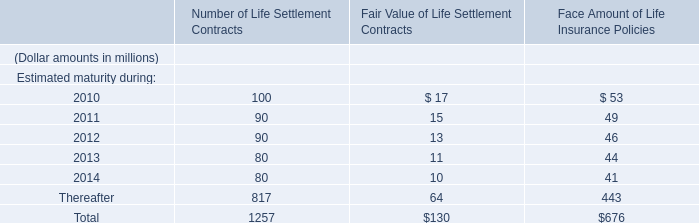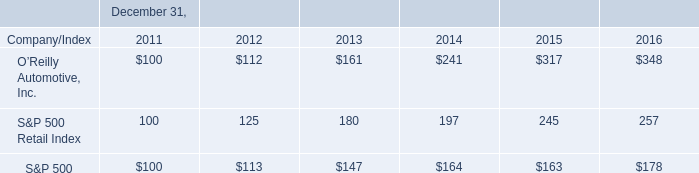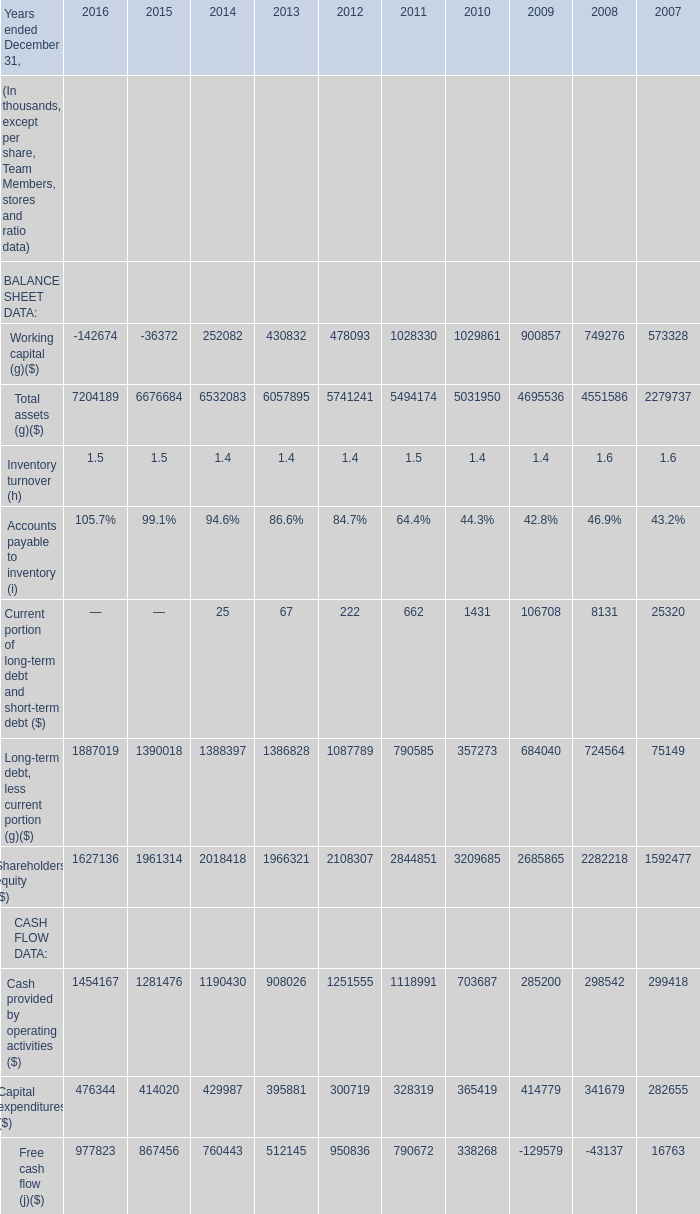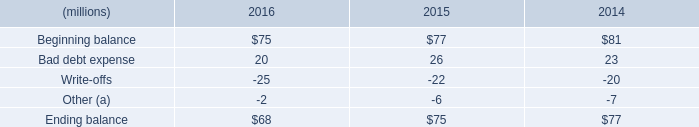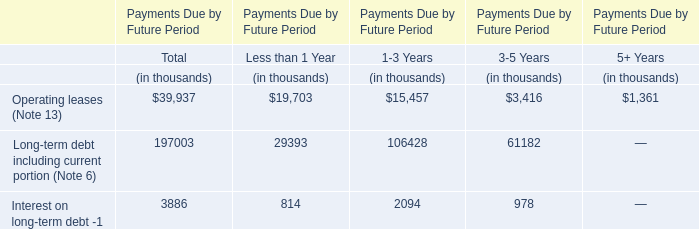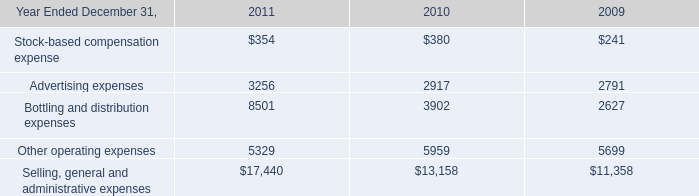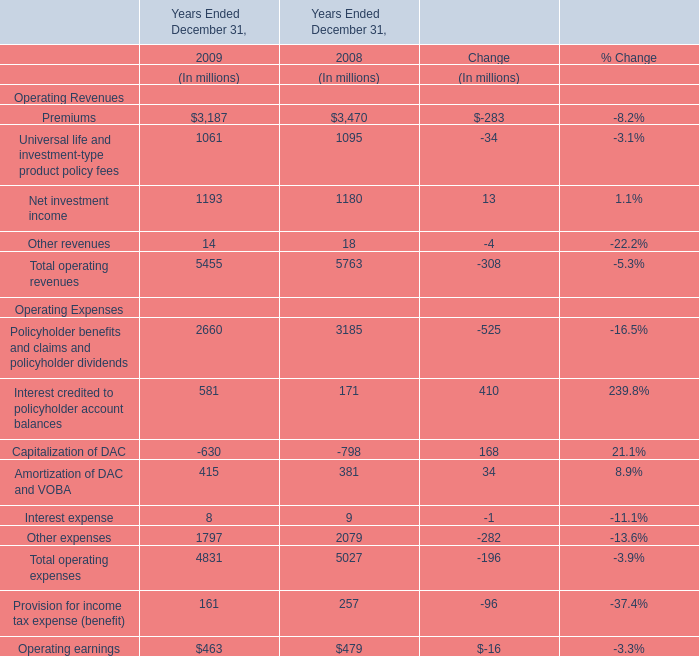What's the growth rate of Cash provided by operating activities in 2010? 
Computations: ((703687 - 285200) / 285200)
Answer: 1.46735. 